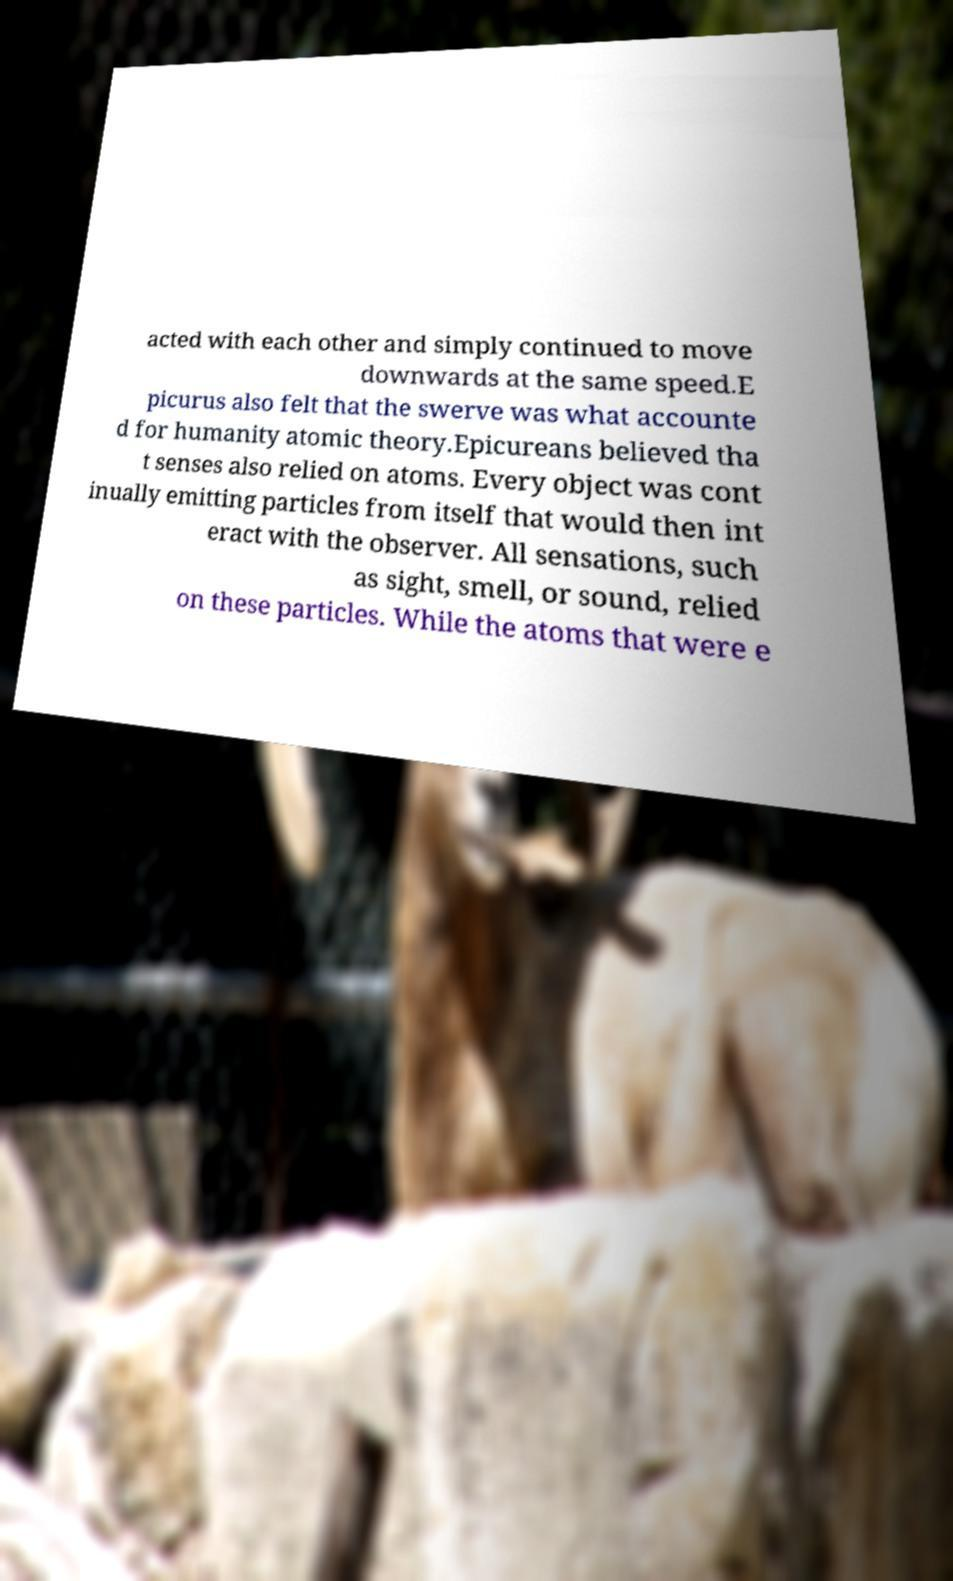Can you accurately transcribe the text from the provided image for me? acted with each other and simply continued to move downwards at the same speed.E picurus also felt that the swerve was what accounte d for humanity atomic theory.Epicureans believed tha t senses also relied on atoms. Every object was cont inually emitting particles from itself that would then int eract with the observer. All sensations, such as sight, smell, or sound, relied on these particles. While the atoms that were e 